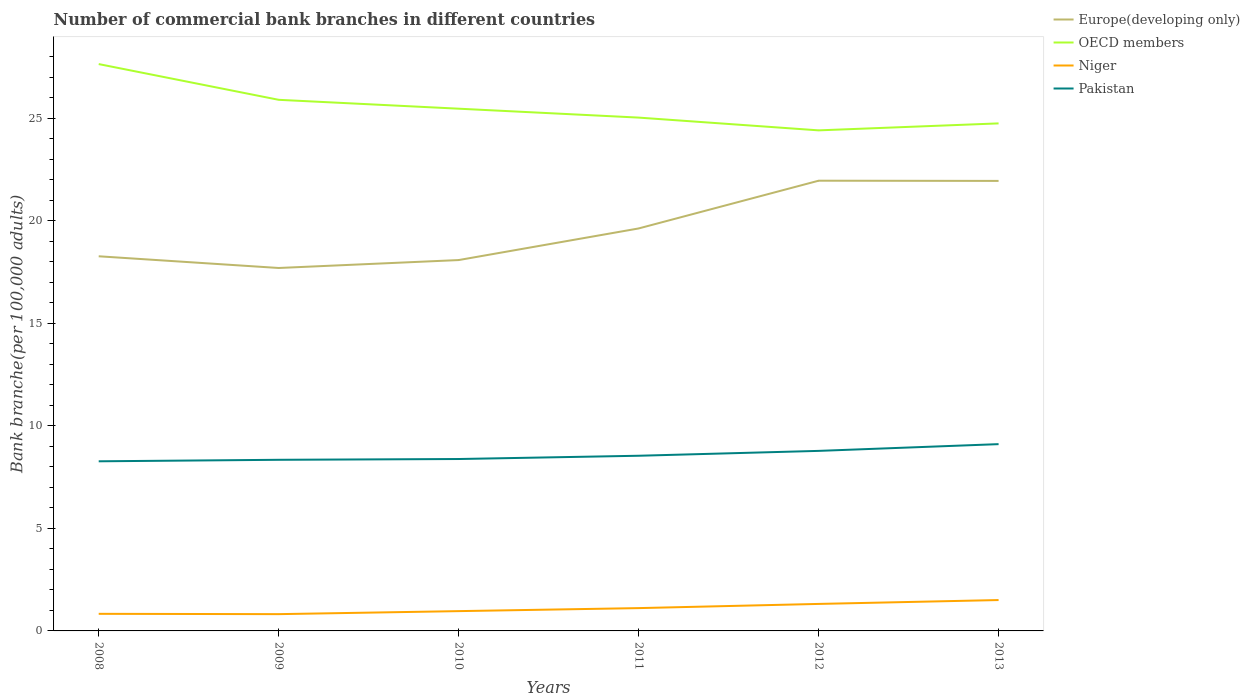How many different coloured lines are there?
Offer a very short reply. 4. Across all years, what is the maximum number of commercial bank branches in Europe(developing only)?
Make the answer very short. 17.7. What is the total number of commercial bank branches in Europe(developing only) in the graph?
Keep it short and to the point. -3.69. What is the difference between the highest and the second highest number of commercial bank branches in Europe(developing only)?
Your response must be concise. 4.26. What is the difference between the highest and the lowest number of commercial bank branches in Niger?
Your response must be concise. 3. Is the number of commercial bank branches in Europe(developing only) strictly greater than the number of commercial bank branches in Niger over the years?
Ensure brevity in your answer.  No. How many lines are there?
Offer a very short reply. 4. Are the values on the major ticks of Y-axis written in scientific E-notation?
Ensure brevity in your answer.  No. Does the graph contain grids?
Give a very brief answer. No. How many legend labels are there?
Keep it short and to the point. 4. What is the title of the graph?
Offer a terse response. Number of commercial bank branches in different countries. Does "Albania" appear as one of the legend labels in the graph?
Keep it short and to the point. No. What is the label or title of the Y-axis?
Make the answer very short. Bank branche(per 100,0 adults). What is the Bank branche(per 100,000 adults) of Europe(developing only) in 2008?
Your response must be concise. 18.27. What is the Bank branche(per 100,000 adults) in OECD members in 2008?
Ensure brevity in your answer.  27.65. What is the Bank branche(per 100,000 adults) in Niger in 2008?
Ensure brevity in your answer.  0.83. What is the Bank branche(per 100,000 adults) of Pakistan in 2008?
Offer a terse response. 8.27. What is the Bank branche(per 100,000 adults) of Europe(developing only) in 2009?
Provide a short and direct response. 17.7. What is the Bank branche(per 100,000 adults) of OECD members in 2009?
Offer a terse response. 25.9. What is the Bank branche(per 100,000 adults) in Niger in 2009?
Your answer should be very brief. 0.82. What is the Bank branche(per 100,000 adults) of Pakistan in 2009?
Offer a very short reply. 8.35. What is the Bank branche(per 100,000 adults) of Europe(developing only) in 2010?
Offer a very short reply. 18.09. What is the Bank branche(per 100,000 adults) in OECD members in 2010?
Your answer should be compact. 25.47. What is the Bank branche(per 100,000 adults) in Niger in 2010?
Your answer should be very brief. 0.97. What is the Bank branche(per 100,000 adults) in Pakistan in 2010?
Provide a succinct answer. 8.38. What is the Bank branche(per 100,000 adults) of Europe(developing only) in 2011?
Keep it short and to the point. 19.63. What is the Bank branche(per 100,000 adults) of OECD members in 2011?
Your answer should be compact. 25.04. What is the Bank branche(per 100,000 adults) in Niger in 2011?
Give a very brief answer. 1.11. What is the Bank branche(per 100,000 adults) in Pakistan in 2011?
Keep it short and to the point. 8.54. What is the Bank branche(per 100,000 adults) of Europe(developing only) in 2012?
Your answer should be very brief. 21.96. What is the Bank branche(per 100,000 adults) of OECD members in 2012?
Your answer should be very brief. 24.41. What is the Bank branche(per 100,000 adults) in Niger in 2012?
Keep it short and to the point. 1.32. What is the Bank branche(per 100,000 adults) of Pakistan in 2012?
Give a very brief answer. 8.78. What is the Bank branche(per 100,000 adults) in Europe(developing only) in 2013?
Ensure brevity in your answer.  21.95. What is the Bank branche(per 100,000 adults) of OECD members in 2013?
Keep it short and to the point. 24.75. What is the Bank branche(per 100,000 adults) of Niger in 2013?
Your answer should be compact. 1.51. What is the Bank branche(per 100,000 adults) of Pakistan in 2013?
Your answer should be very brief. 9.11. Across all years, what is the maximum Bank branche(per 100,000 adults) in Europe(developing only)?
Offer a very short reply. 21.96. Across all years, what is the maximum Bank branche(per 100,000 adults) in OECD members?
Keep it short and to the point. 27.65. Across all years, what is the maximum Bank branche(per 100,000 adults) in Niger?
Your answer should be very brief. 1.51. Across all years, what is the maximum Bank branche(per 100,000 adults) of Pakistan?
Your answer should be very brief. 9.11. Across all years, what is the minimum Bank branche(per 100,000 adults) in Europe(developing only)?
Offer a very short reply. 17.7. Across all years, what is the minimum Bank branche(per 100,000 adults) in OECD members?
Your response must be concise. 24.41. Across all years, what is the minimum Bank branche(per 100,000 adults) of Niger?
Ensure brevity in your answer.  0.82. Across all years, what is the minimum Bank branche(per 100,000 adults) of Pakistan?
Provide a succinct answer. 8.27. What is the total Bank branche(per 100,000 adults) of Europe(developing only) in the graph?
Give a very brief answer. 117.6. What is the total Bank branche(per 100,000 adults) of OECD members in the graph?
Provide a succinct answer. 153.23. What is the total Bank branche(per 100,000 adults) of Niger in the graph?
Offer a very short reply. 6.55. What is the total Bank branche(per 100,000 adults) of Pakistan in the graph?
Ensure brevity in your answer.  51.44. What is the difference between the Bank branche(per 100,000 adults) in Europe(developing only) in 2008 and that in 2009?
Your response must be concise. 0.57. What is the difference between the Bank branche(per 100,000 adults) in OECD members in 2008 and that in 2009?
Give a very brief answer. 1.74. What is the difference between the Bank branche(per 100,000 adults) in Niger in 2008 and that in 2009?
Provide a succinct answer. 0.02. What is the difference between the Bank branche(per 100,000 adults) in Pakistan in 2008 and that in 2009?
Offer a terse response. -0.07. What is the difference between the Bank branche(per 100,000 adults) in Europe(developing only) in 2008 and that in 2010?
Keep it short and to the point. 0.18. What is the difference between the Bank branche(per 100,000 adults) in OECD members in 2008 and that in 2010?
Your answer should be compact. 2.18. What is the difference between the Bank branche(per 100,000 adults) in Niger in 2008 and that in 2010?
Offer a very short reply. -0.13. What is the difference between the Bank branche(per 100,000 adults) of Pakistan in 2008 and that in 2010?
Your response must be concise. -0.11. What is the difference between the Bank branche(per 100,000 adults) in Europe(developing only) in 2008 and that in 2011?
Make the answer very short. -1.36. What is the difference between the Bank branche(per 100,000 adults) of OECD members in 2008 and that in 2011?
Provide a succinct answer. 2.61. What is the difference between the Bank branche(per 100,000 adults) of Niger in 2008 and that in 2011?
Make the answer very short. -0.28. What is the difference between the Bank branche(per 100,000 adults) in Pakistan in 2008 and that in 2011?
Make the answer very short. -0.27. What is the difference between the Bank branche(per 100,000 adults) in Europe(developing only) in 2008 and that in 2012?
Make the answer very short. -3.69. What is the difference between the Bank branche(per 100,000 adults) in OECD members in 2008 and that in 2012?
Provide a succinct answer. 3.23. What is the difference between the Bank branche(per 100,000 adults) in Niger in 2008 and that in 2012?
Your answer should be very brief. -0.48. What is the difference between the Bank branche(per 100,000 adults) in Pakistan in 2008 and that in 2012?
Your answer should be very brief. -0.51. What is the difference between the Bank branche(per 100,000 adults) of Europe(developing only) in 2008 and that in 2013?
Your answer should be compact. -3.68. What is the difference between the Bank branche(per 100,000 adults) of OECD members in 2008 and that in 2013?
Your answer should be compact. 2.89. What is the difference between the Bank branche(per 100,000 adults) in Niger in 2008 and that in 2013?
Provide a short and direct response. -0.67. What is the difference between the Bank branche(per 100,000 adults) in Pakistan in 2008 and that in 2013?
Provide a succinct answer. -0.84. What is the difference between the Bank branche(per 100,000 adults) in Europe(developing only) in 2009 and that in 2010?
Your response must be concise. -0.39. What is the difference between the Bank branche(per 100,000 adults) of OECD members in 2009 and that in 2010?
Your response must be concise. 0.43. What is the difference between the Bank branche(per 100,000 adults) in Niger in 2009 and that in 2010?
Keep it short and to the point. -0.15. What is the difference between the Bank branche(per 100,000 adults) of Pakistan in 2009 and that in 2010?
Provide a succinct answer. -0.04. What is the difference between the Bank branche(per 100,000 adults) of Europe(developing only) in 2009 and that in 2011?
Keep it short and to the point. -1.93. What is the difference between the Bank branche(per 100,000 adults) of OECD members in 2009 and that in 2011?
Your answer should be very brief. 0.87. What is the difference between the Bank branche(per 100,000 adults) of Niger in 2009 and that in 2011?
Your answer should be compact. -0.29. What is the difference between the Bank branche(per 100,000 adults) of Pakistan in 2009 and that in 2011?
Make the answer very short. -0.2. What is the difference between the Bank branche(per 100,000 adults) of Europe(developing only) in 2009 and that in 2012?
Provide a short and direct response. -4.26. What is the difference between the Bank branche(per 100,000 adults) of OECD members in 2009 and that in 2012?
Ensure brevity in your answer.  1.49. What is the difference between the Bank branche(per 100,000 adults) of Niger in 2009 and that in 2012?
Keep it short and to the point. -0.5. What is the difference between the Bank branche(per 100,000 adults) in Pakistan in 2009 and that in 2012?
Offer a very short reply. -0.43. What is the difference between the Bank branche(per 100,000 adults) in Europe(developing only) in 2009 and that in 2013?
Your response must be concise. -4.25. What is the difference between the Bank branche(per 100,000 adults) in OECD members in 2009 and that in 2013?
Your answer should be compact. 1.15. What is the difference between the Bank branche(per 100,000 adults) in Niger in 2009 and that in 2013?
Your response must be concise. -0.69. What is the difference between the Bank branche(per 100,000 adults) in Pakistan in 2009 and that in 2013?
Your response must be concise. -0.76. What is the difference between the Bank branche(per 100,000 adults) of Europe(developing only) in 2010 and that in 2011?
Your response must be concise. -1.54. What is the difference between the Bank branche(per 100,000 adults) of OECD members in 2010 and that in 2011?
Give a very brief answer. 0.43. What is the difference between the Bank branche(per 100,000 adults) of Niger in 2010 and that in 2011?
Your answer should be very brief. -0.15. What is the difference between the Bank branche(per 100,000 adults) of Pakistan in 2010 and that in 2011?
Your answer should be very brief. -0.16. What is the difference between the Bank branche(per 100,000 adults) in Europe(developing only) in 2010 and that in 2012?
Give a very brief answer. -3.87. What is the difference between the Bank branche(per 100,000 adults) of OECD members in 2010 and that in 2012?
Offer a terse response. 1.06. What is the difference between the Bank branche(per 100,000 adults) of Niger in 2010 and that in 2012?
Make the answer very short. -0.35. What is the difference between the Bank branche(per 100,000 adults) of Pakistan in 2010 and that in 2012?
Your answer should be very brief. -0.4. What is the difference between the Bank branche(per 100,000 adults) in Europe(developing only) in 2010 and that in 2013?
Provide a succinct answer. -3.86. What is the difference between the Bank branche(per 100,000 adults) of OECD members in 2010 and that in 2013?
Provide a succinct answer. 0.72. What is the difference between the Bank branche(per 100,000 adults) in Niger in 2010 and that in 2013?
Your answer should be very brief. -0.54. What is the difference between the Bank branche(per 100,000 adults) of Pakistan in 2010 and that in 2013?
Provide a short and direct response. -0.73. What is the difference between the Bank branche(per 100,000 adults) of Europe(developing only) in 2011 and that in 2012?
Ensure brevity in your answer.  -2.33. What is the difference between the Bank branche(per 100,000 adults) of OECD members in 2011 and that in 2012?
Make the answer very short. 0.62. What is the difference between the Bank branche(per 100,000 adults) of Niger in 2011 and that in 2012?
Your answer should be very brief. -0.2. What is the difference between the Bank branche(per 100,000 adults) in Pakistan in 2011 and that in 2012?
Provide a short and direct response. -0.24. What is the difference between the Bank branche(per 100,000 adults) of Europe(developing only) in 2011 and that in 2013?
Ensure brevity in your answer.  -2.32. What is the difference between the Bank branche(per 100,000 adults) in OECD members in 2011 and that in 2013?
Offer a very short reply. 0.28. What is the difference between the Bank branche(per 100,000 adults) of Niger in 2011 and that in 2013?
Your answer should be very brief. -0.39. What is the difference between the Bank branche(per 100,000 adults) in Pakistan in 2011 and that in 2013?
Make the answer very short. -0.57. What is the difference between the Bank branche(per 100,000 adults) in Europe(developing only) in 2012 and that in 2013?
Your answer should be compact. 0.01. What is the difference between the Bank branche(per 100,000 adults) in OECD members in 2012 and that in 2013?
Provide a short and direct response. -0.34. What is the difference between the Bank branche(per 100,000 adults) of Niger in 2012 and that in 2013?
Make the answer very short. -0.19. What is the difference between the Bank branche(per 100,000 adults) of Pakistan in 2012 and that in 2013?
Give a very brief answer. -0.33. What is the difference between the Bank branche(per 100,000 adults) of Europe(developing only) in 2008 and the Bank branche(per 100,000 adults) of OECD members in 2009?
Keep it short and to the point. -7.63. What is the difference between the Bank branche(per 100,000 adults) in Europe(developing only) in 2008 and the Bank branche(per 100,000 adults) in Niger in 2009?
Ensure brevity in your answer.  17.45. What is the difference between the Bank branche(per 100,000 adults) in Europe(developing only) in 2008 and the Bank branche(per 100,000 adults) in Pakistan in 2009?
Keep it short and to the point. 9.93. What is the difference between the Bank branche(per 100,000 adults) in OECD members in 2008 and the Bank branche(per 100,000 adults) in Niger in 2009?
Provide a short and direct response. 26.83. What is the difference between the Bank branche(per 100,000 adults) in OECD members in 2008 and the Bank branche(per 100,000 adults) in Pakistan in 2009?
Your response must be concise. 19.3. What is the difference between the Bank branche(per 100,000 adults) in Niger in 2008 and the Bank branche(per 100,000 adults) in Pakistan in 2009?
Make the answer very short. -7.51. What is the difference between the Bank branche(per 100,000 adults) of Europe(developing only) in 2008 and the Bank branche(per 100,000 adults) of OECD members in 2010?
Your response must be concise. -7.2. What is the difference between the Bank branche(per 100,000 adults) in Europe(developing only) in 2008 and the Bank branche(per 100,000 adults) in Niger in 2010?
Keep it short and to the point. 17.31. What is the difference between the Bank branche(per 100,000 adults) of Europe(developing only) in 2008 and the Bank branche(per 100,000 adults) of Pakistan in 2010?
Make the answer very short. 9.89. What is the difference between the Bank branche(per 100,000 adults) in OECD members in 2008 and the Bank branche(per 100,000 adults) in Niger in 2010?
Offer a terse response. 26.68. What is the difference between the Bank branche(per 100,000 adults) of OECD members in 2008 and the Bank branche(per 100,000 adults) of Pakistan in 2010?
Provide a succinct answer. 19.26. What is the difference between the Bank branche(per 100,000 adults) in Niger in 2008 and the Bank branche(per 100,000 adults) in Pakistan in 2010?
Your response must be concise. -7.55. What is the difference between the Bank branche(per 100,000 adults) in Europe(developing only) in 2008 and the Bank branche(per 100,000 adults) in OECD members in 2011?
Your answer should be compact. -6.76. What is the difference between the Bank branche(per 100,000 adults) in Europe(developing only) in 2008 and the Bank branche(per 100,000 adults) in Niger in 2011?
Keep it short and to the point. 17.16. What is the difference between the Bank branche(per 100,000 adults) in Europe(developing only) in 2008 and the Bank branche(per 100,000 adults) in Pakistan in 2011?
Provide a short and direct response. 9.73. What is the difference between the Bank branche(per 100,000 adults) in OECD members in 2008 and the Bank branche(per 100,000 adults) in Niger in 2011?
Offer a terse response. 26.53. What is the difference between the Bank branche(per 100,000 adults) of OECD members in 2008 and the Bank branche(per 100,000 adults) of Pakistan in 2011?
Offer a very short reply. 19.1. What is the difference between the Bank branche(per 100,000 adults) of Niger in 2008 and the Bank branche(per 100,000 adults) of Pakistan in 2011?
Provide a short and direct response. -7.71. What is the difference between the Bank branche(per 100,000 adults) in Europe(developing only) in 2008 and the Bank branche(per 100,000 adults) in OECD members in 2012?
Offer a terse response. -6.14. What is the difference between the Bank branche(per 100,000 adults) of Europe(developing only) in 2008 and the Bank branche(per 100,000 adults) of Niger in 2012?
Ensure brevity in your answer.  16.96. What is the difference between the Bank branche(per 100,000 adults) of Europe(developing only) in 2008 and the Bank branche(per 100,000 adults) of Pakistan in 2012?
Make the answer very short. 9.49. What is the difference between the Bank branche(per 100,000 adults) of OECD members in 2008 and the Bank branche(per 100,000 adults) of Niger in 2012?
Your answer should be very brief. 26.33. What is the difference between the Bank branche(per 100,000 adults) in OECD members in 2008 and the Bank branche(per 100,000 adults) in Pakistan in 2012?
Make the answer very short. 18.87. What is the difference between the Bank branche(per 100,000 adults) in Niger in 2008 and the Bank branche(per 100,000 adults) in Pakistan in 2012?
Ensure brevity in your answer.  -7.95. What is the difference between the Bank branche(per 100,000 adults) in Europe(developing only) in 2008 and the Bank branche(per 100,000 adults) in OECD members in 2013?
Keep it short and to the point. -6.48. What is the difference between the Bank branche(per 100,000 adults) of Europe(developing only) in 2008 and the Bank branche(per 100,000 adults) of Niger in 2013?
Provide a succinct answer. 16.77. What is the difference between the Bank branche(per 100,000 adults) in Europe(developing only) in 2008 and the Bank branche(per 100,000 adults) in Pakistan in 2013?
Your answer should be very brief. 9.16. What is the difference between the Bank branche(per 100,000 adults) of OECD members in 2008 and the Bank branche(per 100,000 adults) of Niger in 2013?
Keep it short and to the point. 26.14. What is the difference between the Bank branche(per 100,000 adults) in OECD members in 2008 and the Bank branche(per 100,000 adults) in Pakistan in 2013?
Keep it short and to the point. 18.54. What is the difference between the Bank branche(per 100,000 adults) in Niger in 2008 and the Bank branche(per 100,000 adults) in Pakistan in 2013?
Give a very brief answer. -8.28. What is the difference between the Bank branche(per 100,000 adults) of Europe(developing only) in 2009 and the Bank branche(per 100,000 adults) of OECD members in 2010?
Offer a terse response. -7.77. What is the difference between the Bank branche(per 100,000 adults) of Europe(developing only) in 2009 and the Bank branche(per 100,000 adults) of Niger in 2010?
Your answer should be very brief. 16.74. What is the difference between the Bank branche(per 100,000 adults) of Europe(developing only) in 2009 and the Bank branche(per 100,000 adults) of Pakistan in 2010?
Your answer should be compact. 9.32. What is the difference between the Bank branche(per 100,000 adults) of OECD members in 2009 and the Bank branche(per 100,000 adults) of Niger in 2010?
Give a very brief answer. 24.94. What is the difference between the Bank branche(per 100,000 adults) in OECD members in 2009 and the Bank branche(per 100,000 adults) in Pakistan in 2010?
Your answer should be very brief. 17.52. What is the difference between the Bank branche(per 100,000 adults) in Niger in 2009 and the Bank branche(per 100,000 adults) in Pakistan in 2010?
Ensure brevity in your answer.  -7.57. What is the difference between the Bank branche(per 100,000 adults) in Europe(developing only) in 2009 and the Bank branche(per 100,000 adults) in OECD members in 2011?
Your answer should be very brief. -7.34. What is the difference between the Bank branche(per 100,000 adults) of Europe(developing only) in 2009 and the Bank branche(per 100,000 adults) of Niger in 2011?
Make the answer very short. 16.59. What is the difference between the Bank branche(per 100,000 adults) in Europe(developing only) in 2009 and the Bank branche(per 100,000 adults) in Pakistan in 2011?
Your answer should be very brief. 9.16. What is the difference between the Bank branche(per 100,000 adults) of OECD members in 2009 and the Bank branche(per 100,000 adults) of Niger in 2011?
Provide a succinct answer. 24.79. What is the difference between the Bank branche(per 100,000 adults) in OECD members in 2009 and the Bank branche(per 100,000 adults) in Pakistan in 2011?
Your answer should be compact. 17.36. What is the difference between the Bank branche(per 100,000 adults) of Niger in 2009 and the Bank branche(per 100,000 adults) of Pakistan in 2011?
Offer a terse response. -7.73. What is the difference between the Bank branche(per 100,000 adults) in Europe(developing only) in 2009 and the Bank branche(per 100,000 adults) in OECD members in 2012?
Your response must be concise. -6.71. What is the difference between the Bank branche(per 100,000 adults) in Europe(developing only) in 2009 and the Bank branche(per 100,000 adults) in Niger in 2012?
Keep it short and to the point. 16.39. What is the difference between the Bank branche(per 100,000 adults) of Europe(developing only) in 2009 and the Bank branche(per 100,000 adults) of Pakistan in 2012?
Your answer should be very brief. 8.92. What is the difference between the Bank branche(per 100,000 adults) in OECD members in 2009 and the Bank branche(per 100,000 adults) in Niger in 2012?
Your answer should be very brief. 24.59. What is the difference between the Bank branche(per 100,000 adults) in OECD members in 2009 and the Bank branche(per 100,000 adults) in Pakistan in 2012?
Provide a short and direct response. 17.12. What is the difference between the Bank branche(per 100,000 adults) in Niger in 2009 and the Bank branche(per 100,000 adults) in Pakistan in 2012?
Give a very brief answer. -7.96. What is the difference between the Bank branche(per 100,000 adults) of Europe(developing only) in 2009 and the Bank branche(per 100,000 adults) of OECD members in 2013?
Make the answer very short. -7.05. What is the difference between the Bank branche(per 100,000 adults) in Europe(developing only) in 2009 and the Bank branche(per 100,000 adults) in Niger in 2013?
Keep it short and to the point. 16.2. What is the difference between the Bank branche(per 100,000 adults) in Europe(developing only) in 2009 and the Bank branche(per 100,000 adults) in Pakistan in 2013?
Provide a short and direct response. 8.59. What is the difference between the Bank branche(per 100,000 adults) of OECD members in 2009 and the Bank branche(per 100,000 adults) of Niger in 2013?
Provide a short and direct response. 24.4. What is the difference between the Bank branche(per 100,000 adults) in OECD members in 2009 and the Bank branche(per 100,000 adults) in Pakistan in 2013?
Keep it short and to the point. 16.79. What is the difference between the Bank branche(per 100,000 adults) in Niger in 2009 and the Bank branche(per 100,000 adults) in Pakistan in 2013?
Your response must be concise. -8.29. What is the difference between the Bank branche(per 100,000 adults) of Europe(developing only) in 2010 and the Bank branche(per 100,000 adults) of OECD members in 2011?
Offer a terse response. -6.95. What is the difference between the Bank branche(per 100,000 adults) of Europe(developing only) in 2010 and the Bank branche(per 100,000 adults) of Niger in 2011?
Your answer should be compact. 16.98. What is the difference between the Bank branche(per 100,000 adults) of Europe(developing only) in 2010 and the Bank branche(per 100,000 adults) of Pakistan in 2011?
Your response must be concise. 9.54. What is the difference between the Bank branche(per 100,000 adults) in OECD members in 2010 and the Bank branche(per 100,000 adults) in Niger in 2011?
Ensure brevity in your answer.  24.36. What is the difference between the Bank branche(per 100,000 adults) of OECD members in 2010 and the Bank branche(per 100,000 adults) of Pakistan in 2011?
Provide a succinct answer. 16.93. What is the difference between the Bank branche(per 100,000 adults) of Niger in 2010 and the Bank branche(per 100,000 adults) of Pakistan in 2011?
Keep it short and to the point. -7.58. What is the difference between the Bank branche(per 100,000 adults) of Europe(developing only) in 2010 and the Bank branche(per 100,000 adults) of OECD members in 2012?
Provide a succinct answer. -6.33. What is the difference between the Bank branche(per 100,000 adults) in Europe(developing only) in 2010 and the Bank branche(per 100,000 adults) in Niger in 2012?
Keep it short and to the point. 16.77. What is the difference between the Bank branche(per 100,000 adults) of Europe(developing only) in 2010 and the Bank branche(per 100,000 adults) of Pakistan in 2012?
Your response must be concise. 9.31. What is the difference between the Bank branche(per 100,000 adults) in OECD members in 2010 and the Bank branche(per 100,000 adults) in Niger in 2012?
Your response must be concise. 24.15. What is the difference between the Bank branche(per 100,000 adults) in OECD members in 2010 and the Bank branche(per 100,000 adults) in Pakistan in 2012?
Provide a short and direct response. 16.69. What is the difference between the Bank branche(per 100,000 adults) of Niger in 2010 and the Bank branche(per 100,000 adults) of Pakistan in 2012?
Offer a terse response. -7.82. What is the difference between the Bank branche(per 100,000 adults) in Europe(developing only) in 2010 and the Bank branche(per 100,000 adults) in OECD members in 2013?
Provide a short and direct response. -6.67. What is the difference between the Bank branche(per 100,000 adults) in Europe(developing only) in 2010 and the Bank branche(per 100,000 adults) in Niger in 2013?
Offer a terse response. 16.58. What is the difference between the Bank branche(per 100,000 adults) in Europe(developing only) in 2010 and the Bank branche(per 100,000 adults) in Pakistan in 2013?
Your answer should be compact. 8.98. What is the difference between the Bank branche(per 100,000 adults) of OECD members in 2010 and the Bank branche(per 100,000 adults) of Niger in 2013?
Offer a terse response. 23.97. What is the difference between the Bank branche(per 100,000 adults) of OECD members in 2010 and the Bank branche(per 100,000 adults) of Pakistan in 2013?
Your response must be concise. 16.36. What is the difference between the Bank branche(per 100,000 adults) in Niger in 2010 and the Bank branche(per 100,000 adults) in Pakistan in 2013?
Ensure brevity in your answer.  -8.14. What is the difference between the Bank branche(per 100,000 adults) of Europe(developing only) in 2011 and the Bank branche(per 100,000 adults) of OECD members in 2012?
Make the answer very short. -4.78. What is the difference between the Bank branche(per 100,000 adults) of Europe(developing only) in 2011 and the Bank branche(per 100,000 adults) of Niger in 2012?
Offer a terse response. 18.31. What is the difference between the Bank branche(per 100,000 adults) in Europe(developing only) in 2011 and the Bank branche(per 100,000 adults) in Pakistan in 2012?
Provide a short and direct response. 10.85. What is the difference between the Bank branche(per 100,000 adults) of OECD members in 2011 and the Bank branche(per 100,000 adults) of Niger in 2012?
Offer a terse response. 23.72. What is the difference between the Bank branche(per 100,000 adults) of OECD members in 2011 and the Bank branche(per 100,000 adults) of Pakistan in 2012?
Your response must be concise. 16.26. What is the difference between the Bank branche(per 100,000 adults) in Niger in 2011 and the Bank branche(per 100,000 adults) in Pakistan in 2012?
Your answer should be very brief. -7.67. What is the difference between the Bank branche(per 100,000 adults) of Europe(developing only) in 2011 and the Bank branche(per 100,000 adults) of OECD members in 2013?
Offer a terse response. -5.12. What is the difference between the Bank branche(per 100,000 adults) in Europe(developing only) in 2011 and the Bank branche(per 100,000 adults) in Niger in 2013?
Offer a very short reply. 18.12. What is the difference between the Bank branche(per 100,000 adults) in Europe(developing only) in 2011 and the Bank branche(per 100,000 adults) in Pakistan in 2013?
Make the answer very short. 10.52. What is the difference between the Bank branche(per 100,000 adults) in OECD members in 2011 and the Bank branche(per 100,000 adults) in Niger in 2013?
Keep it short and to the point. 23.53. What is the difference between the Bank branche(per 100,000 adults) in OECD members in 2011 and the Bank branche(per 100,000 adults) in Pakistan in 2013?
Keep it short and to the point. 15.93. What is the difference between the Bank branche(per 100,000 adults) in Niger in 2011 and the Bank branche(per 100,000 adults) in Pakistan in 2013?
Offer a terse response. -8. What is the difference between the Bank branche(per 100,000 adults) of Europe(developing only) in 2012 and the Bank branche(per 100,000 adults) of OECD members in 2013?
Your response must be concise. -2.8. What is the difference between the Bank branche(per 100,000 adults) in Europe(developing only) in 2012 and the Bank branche(per 100,000 adults) in Niger in 2013?
Ensure brevity in your answer.  20.45. What is the difference between the Bank branche(per 100,000 adults) in Europe(developing only) in 2012 and the Bank branche(per 100,000 adults) in Pakistan in 2013?
Keep it short and to the point. 12.85. What is the difference between the Bank branche(per 100,000 adults) in OECD members in 2012 and the Bank branche(per 100,000 adults) in Niger in 2013?
Offer a very short reply. 22.91. What is the difference between the Bank branche(per 100,000 adults) of OECD members in 2012 and the Bank branche(per 100,000 adults) of Pakistan in 2013?
Keep it short and to the point. 15.3. What is the difference between the Bank branche(per 100,000 adults) of Niger in 2012 and the Bank branche(per 100,000 adults) of Pakistan in 2013?
Keep it short and to the point. -7.79. What is the average Bank branche(per 100,000 adults) of Europe(developing only) per year?
Give a very brief answer. 19.6. What is the average Bank branche(per 100,000 adults) in OECD members per year?
Offer a terse response. 25.54. What is the average Bank branche(per 100,000 adults) of Niger per year?
Your response must be concise. 1.09. What is the average Bank branche(per 100,000 adults) of Pakistan per year?
Offer a very short reply. 8.57. In the year 2008, what is the difference between the Bank branche(per 100,000 adults) of Europe(developing only) and Bank branche(per 100,000 adults) of OECD members?
Your answer should be very brief. -9.37. In the year 2008, what is the difference between the Bank branche(per 100,000 adults) of Europe(developing only) and Bank branche(per 100,000 adults) of Niger?
Ensure brevity in your answer.  17.44. In the year 2008, what is the difference between the Bank branche(per 100,000 adults) in Europe(developing only) and Bank branche(per 100,000 adults) in Pakistan?
Your answer should be very brief. 10. In the year 2008, what is the difference between the Bank branche(per 100,000 adults) of OECD members and Bank branche(per 100,000 adults) of Niger?
Make the answer very short. 26.81. In the year 2008, what is the difference between the Bank branche(per 100,000 adults) of OECD members and Bank branche(per 100,000 adults) of Pakistan?
Your answer should be compact. 19.37. In the year 2008, what is the difference between the Bank branche(per 100,000 adults) in Niger and Bank branche(per 100,000 adults) in Pakistan?
Keep it short and to the point. -7.44. In the year 2009, what is the difference between the Bank branche(per 100,000 adults) of Europe(developing only) and Bank branche(per 100,000 adults) of OECD members?
Make the answer very short. -8.2. In the year 2009, what is the difference between the Bank branche(per 100,000 adults) in Europe(developing only) and Bank branche(per 100,000 adults) in Niger?
Offer a terse response. 16.88. In the year 2009, what is the difference between the Bank branche(per 100,000 adults) of Europe(developing only) and Bank branche(per 100,000 adults) of Pakistan?
Provide a succinct answer. 9.36. In the year 2009, what is the difference between the Bank branche(per 100,000 adults) in OECD members and Bank branche(per 100,000 adults) in Niger?
Give a very brief answer. 25.09. In the year 2009, what is the difference between the Bank branche(per 100,000 adults) in OECD members and Bank branche(per 100,000 adults) in Pakistan?
Make the answer very short. 17.56. In the year 2009, what is the difference between the Bank branche(per 100,000 adults) of Niger and Bank branche(per 100,000 adults) of Pakistan?
Your response must be concise. -7.53. In the year 2010, what is the difference between the Bank branche(per 100,000 adults) in Europe(developing only) and Bank branche(per 100,000 adults) in OECD members?
Ensure brevity in your answer.  -7.38. In the year 2010, what is the difference between the Bank branche(per 100,000 adults) in Europe(developing only) and Bank branche(per 100,000 adults) in Niger?
Your response must be concise. 17.12. In the year 2010, what is the difference between the Bank branche(per 100,000 adults) in Europe(developing only) and Bank branche(per 100,000 adults) in Pakistan?
Keep it short and to the point. 9.7. In the year 2010, what is the difference between the Bank branche(per 100,000 adults) in OECD members and Bank branche(per 100,000 adults) in Niger?
Give a very brief answer. 24.51. In the year 2010, what is the difference between the Bank branche(per 100,000 adults) in OECD members and Bank branche(per 100,000 adults) in Pakistan?
Offer a terse response. 17.09. In the year 2010, what is the difference between the Bank branche(per 100,000 adults) of Niger and Bank branche(per 100,000 adults) of Pakistan?
Offer a terse response. -7.42. In the year 2011, what is the difference between the Bank branche(per 100,000 adults) of Europe(developing only) and Bank branche(per 100,000 adults) of OECD members?
Your answer should be very brief. -5.41. In the year 2011, what is the difference between the Bank branche(per 100,000 adults) in Europe(developing only) and Bank branche(per 100,000 adults) in Niger?
Give a very brief answer. 18.52. In the year 2011, what is the difference between the Bank branche(per 100,000 adults) of Europe(developing only) and Bank branche(per 100,000 adults) of Pakistan?
Your response must be concise. 11.09. In the year 2011, what is the difference between the Bank branche(per 100,000 adults) of OECD members and Bank branche(per 100,000 adults) of Niger?
Make the answer very short. 23.92. In the year 2011, what is the difference between the Bank branche(per 100,000 adults) of OECD members and Bank branche(per 100,000 adults) of Pakistan?
Your answer should be compact. 16.49. In the year 2011, what is the difference between the Bank branche(per 100,000 adults) of Niger and Bank branche(per 100,000 adults) of Pakistan?
Offer a very short reply. -7.43. In the year 2012, what is the difference between the Bank branche(per 100,000 adults) in Europe(developing only) and Bank branche(per 100,000 adults) in OECD members?
Keep it short and to the point. -2.46. In the year 2012, what is the difference between the Bank branche(per 100,000 adults) in Europe(developing only) and Bank branche(per 100,000 adults) in Niger?
Offer a terse response. 20.64. In the year 2012, what is the difference between the Bank branche(per 100,000 adults) of Europe(developing only) and Bank branche(per 100,000 adults) of Pakistan?
Make the answer very short. 13.18. In the year 2012, what is the difference between the Bank branche(per 100,000 adults) of OECD members and Bank branche(per 100,000 adults) of Niger?
Offer a terse response. 23.1. In the year 2012, what is the difference between the Bank branche(per 100,000 adults) of OECD members and Bank branche(per 100,000 adults) of Pakistan?
Provide a succinct answer. 15.63. In the year 2012, what is the difference between the Bank branche(per 100,000 adults) of Niger and Bank branche(per 100,000 adults) of Pakistan?
Make the answer very short. -7.46. In the year 2013, what is the difference between the Bank branche(per 100,000 adults) in Europe(developing only) and Bank branche(per 100,000 adults) in OECD members?
Provide a short and direct response. -2.8. In the year 2013, what is the difference between the Bank branche(per 100,000 adults) in Europe(developing only) and Bank branche(per 100,000 adults) in Niger?
Make the answer very short. 20.44. In the year 2013, what is the difference between the Bank branche(per 100,000 adults) of Europe(developing only) and Bank branche(per 100,000 adults) of Pakistan?
Make the answer very short. 12.84. In the year 2013, what is the difference between the Bank branche(per 100,000 adults) in OECD members and Bank branche(per 100,000 adults) in Niger?
Your answer should be very brief. 23.25. In the year 2013, what is the difference between the Bank branche(per 100,000 adults) in OECD members and Bank branche(per 100,000 adults) in Pakistan?
Give a very brief answer. 15.64. In the year 2013, what is the difference between the Bank branche(per 100,000 adults) of Niger and Bank branche(per 100,000 adults) of Pakistan?
Ensure brevity in your answer.  -7.6. What is the ratio of the Bank branche(per 100,000 adults) of Europe(developing only) in 2008 to that in 2009?
Give a very brief answer. 1.03. What is the ratio of the Bank branche(per 100,000 adults) of OECD members in 2008 to that in 2009?
Your answer should be very brief. 1.07. What is the ratio of the Bank branche(per 100,000 adults) in Niger in 2008 to that in 2009?
Provide a short and direct response. 1.02. What is the ratio of the Bank branche(per 100,000 adults) in Europe(developing only) in 2008 to that in 2010?
Your answer should be very brief. 1.01. What is the ratio of the Bank branche(per 100,000 adults) of OECD members in 2008 to that in 2010?
Your response must be concise. 1.09. What is the ratio of the Bank branche(per 100,000 adults) in Niger in 2008 to that in 2010?
Offer a very short reply. 0.86. What is the ratio of the Bank branche(per 100,000 adults) of Pakistan in 2008 to that in 2010?
Your answer should be compact. 0.99. What is the ratio of the Bank branche(per 100,000 adults) of Europe(developing only) in 2008 to that in 2011?
Provide a short and direct response. 0.93. What is the ratio of the Bank branche(per 100,000 adults) in OECD members in 2008 to that in 2011?
Your answer should be very brief. 1.1. What is the ratio of the Bank branche(per 100,000 adults) of Niger in 2008 to that in 2011?
Your response must be concise. 0.75. What is the ratio of the Bank branche(per 100,000 adults) in Pakistan in 2008 to that in 2011?
Offer a terse response. 0.97. What is the ratio of the Bank branche(per 100,000 adults) in Europe(developing only) in 2008 to that in 2012?
Your answer should be very brief. 0.83. What is the ratio of the Bank branche(per 100,000 adults) in OECD members in 2008 to that in 2012?
Offer a very short reply. 1.13. What is the ratio of the Bank branche(per 100,000 adults) of Niger in 2008 to that in 2012?
Your answer should be compact. 0.63. What is the ratio of the Bank branche(per 100,000 adults) in Pakistan in 2008 to that in 2012?
Offer a terse response. 0.94. What is the ratio of the Bank branche(per 100,000 adults) of Europe(developing only) in 2008 to that in 2013?
Your answer should be very brief. 0.83. What is the ratio of the Bank branche(per 100,000 adults) of OECD members in 2008 to that in 2013?
Your answer should be very brief. 1.12. What is the ratio of the Bank branche(per 100,000 adults) of Niger in 2008 to that in 2013?
Your response must be concise. 0.55. What is the ratio of the Bank branche(per 100,000 adults) in Pakistan in 2008 to that in 2013?
Ensure brevity in your answer.  0.91. What is the ratio of the Bank branche(per 100,000 adults) in Europe(developing only) in 2009 to that in 2010?
Provide a succinct answer. 0.98. What is the ratio of the Bank branche(per 100,000 adults) of Niger in 2009 to that in 2010?
Your answer should be very brief. 0.85. What is the ratio of the Bank branche(per 100,000 adults) in Pakistan in 2009 to that in 2010?
Offer a terse response. 1. What is the ratio of the Bank branche(per 100,000 adults) in Europe(developing only) in 2009 to that in 2011?
Keep it short and to the point. 0.9. What is the ratio of the Bank branche(per 100,000 adults) of OECD members in 2009 to that in 2011?
Provide a succinct answer. 1.03. What is the ratio of the Bank branche(per 100,000 adults) in Niger in 2009 to that in 2011?
Make the answer very short. 0.74. What is the ratio of the Bank branche(per 100,000 adults) of Pakistan in 2009 to that in 2011?
Your answer should be very brief. 0.98. What is the ratio of the Bank branche(per 100,000 adults) in Europe(developing only) in 2009 to that in 2012?
Offer a terse response. 0.81. What is the ratio of the Bank branche(per 100,000 adults) of OECD members in 2009 to that in 2012?
Offer a very short reply. 1.06. What is the ratio of the Bank branche(per 100,000 adults) in Niger in 2009 to that in 2012?
Provide a succinct answer. 0.62. What is the ratio of the Bank branche(per 100,000 adults) of Pakistan in 2009 to that in 2012?
Ensure brevity in your answer.  0.95. What is the ratio of the Bank branche(per 100,000 adults) in Europe(developing only) in 2009 to that in 2013?
Offer a terse response. 0.81. What is the ratio of the Bank branche(per 100,000 adults) in OECD members in 2009 to that in 2013?
Your answer should be very brief. 1.05. What is the ratio of the Bank branche(per 100,000 adults) of Niger in 2009 to that in 2013?
Provide a succinct answer. 0.54. What is the ratio of the Bank branche(per 100,000 adults) in Pakistan in 2009 to that in 2013?
Give a very brief answer. 0.92. What is the ratio of the Bank branche(per 100,000 adults) of Europe(developing only) in 2010 to that in 2011?
Your response must be concise. 0.92. What is the ratio of the Bank branche(per 100,000 adults) of OECD members in 2010 to that in 2011?
Your response must be concise. 1.02. What is the ratio of the Bank branche(per 100,000 adults) in Niger in 2010 to that in 2011?
Offer a terse response. 0.87. What is the ratio of the Bank branche(per 100,000 adults) in Pakistan in 2010 to that in 2011?
Provide a succinct answer. 0.98. What is the ratio of the Bank branche(per 100,000 adults) of Europe(developing only) in 2010 to that in 2012?
Your answer should be very brief. 0.82. What is the ratio of the Bank branche(per 100,000 adults) in OECD members in 2010 to that in 2012?
Your answer should be compact. 1.04. What is the ratio of the Bank branche(per 100,000 adults) of Niger in 2010 to that in 2012?
Provide a succinct answer. 0.73. What is the ratio of the Bank branche(per 100,000 adults) of Pakistan in 2010 to that in 2012?
Your answer should be very brief. 0.95. What is the ratio of the Bank branche(per 100,000 adults) in Europe(developing only) in 2010 to that in 2013?
Provide a succinct answer. 0.82. What is the ratio of the Bank branche(per 100,000 adults) in Niger in 2010 to that in 2013?
Offer a terse response. 0.64. What is the ratio of the Bank branche(per 100,000 adults) of Pakistan in 2010 to that in 2013?
Provide a short and direct response. 0.92. What is the ratio of the Bank branche(per 100,000 adults) of Europe(developing only) in 2011 to that in 2012?
Your answer should be very brief. 0.89. What is the ratio of the Bank branche(per 100,000 adults) in OECD members in 2011 to that in 2012?
Offer a terse response. 1.03. What is the ratio of the Bank branche(per 100,000 adults) in Niger in 2011 to that in 2012?
Keep it short and to the point. 0.84. What is the ratio of the Bank branche(per 100,000 adults) of Pakistan in 2011 to that in 2012?
Your response must be concise. 0.97. What is the ratio of the Bank branche(per 100,000 adults) in Europe(developing only) in 2011 to that in 2013?
Your response must be concise. 0.89. What is the ratio of the Bank branche(per 100,000 adults) in OECD members in 2011 to that in 2013?
Your answer should be compact. 1.01. What is the ratio of the Bank branche(per 100,000 adults) of Niger in 2011 to that in 2013?
Offer a terse response. 0.74. What is the ratio of the Bank branche(per 100,000 adults) of Pakistan in 2011 to that in 2013?
Provide a succinct answer. 0.94. What is the ratio of the Bank branche(per 100,000 adults) of OECD members in 2012 to that in 2013?
Your answer should be compact. 0.99. What is the ratio of the Bank branche(per 100,000 adults) in Niger in 2012 to that in 2013?
Give a very brief answer. 0.87. What is the ratio of the Bank branche(per 100,000 adults) of Pakistan in 2012 to that in 2013?
Provide a succinct answer. 0.96. What is the difference between the highest and the second highest Bank branche(per 100,000 adults) in Europe(developing only)?
Give a very brief answer. 0.01. What is the difference between the highest and the second highest Bank branche(per 100,000 adults) in OECD members?
Offer a terse response. 1.74. What is the difference between the highest and the second highest Bank branche(per 100,000 adults) of Niger?
Provide a short and direct response. 0.19. What is the difference between the highest and the second highest Bank branche(per 100,000 adults) of Pakistan?
Make the answer very short. 0.33. What is the difference between the highest and the lowest Bank branche(per 100,000 adults) in Europe(developing only)?
Offer a very short reply. 4.26. What is the difference between the highest and the lowest Bank branche(per 100,000 adults) of OECD members?
Make the answer very short. 3.23. What is the difference between the highest and the lowest Bank branche(per 100,000 adults) of Niger?
Offer a very short reply. 0.69. What is the difference between the highest and the lowest Bank branche(per 100,000 adults) in Pakistan?
Provide a succinct answer. 0.84. 